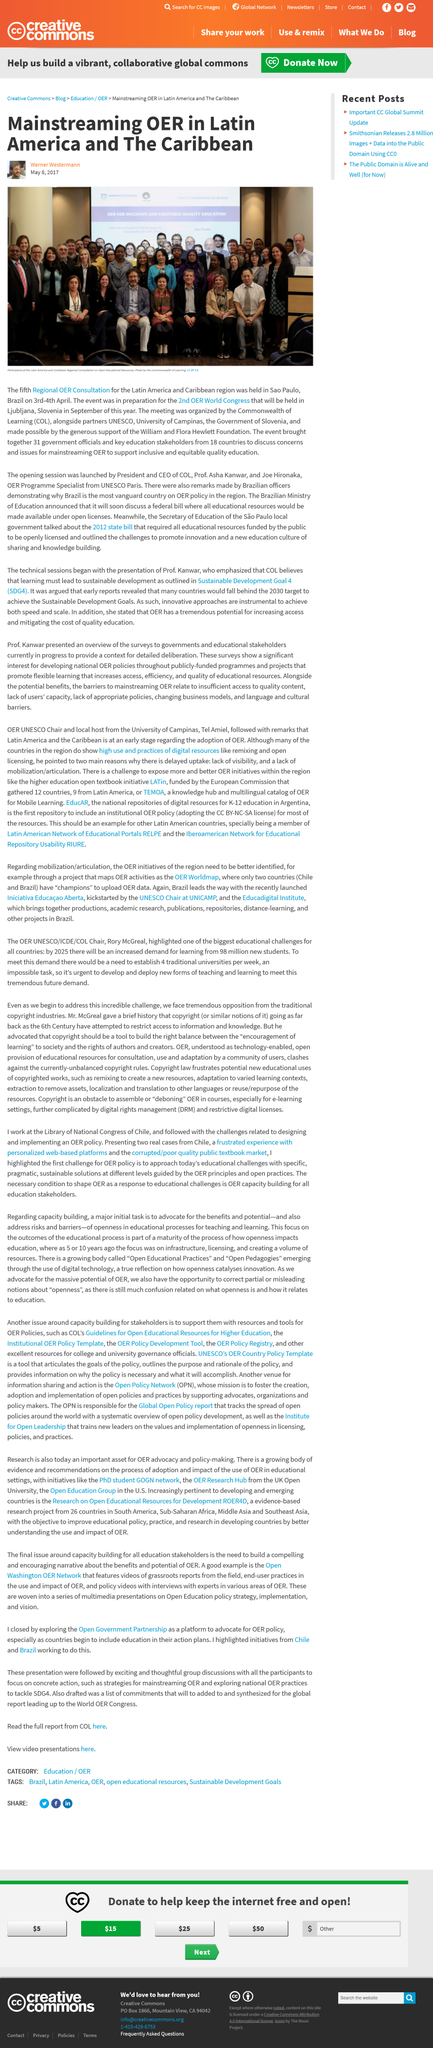Identify some key points in this picture. The 2nd OER World Congress will be held in Ljubljana, Slovenia. The fifth Regional OER Consultation for the Latin America Caribbean region was held in Sao Paulo, Brazil. The article was written by Werner Westermann. 